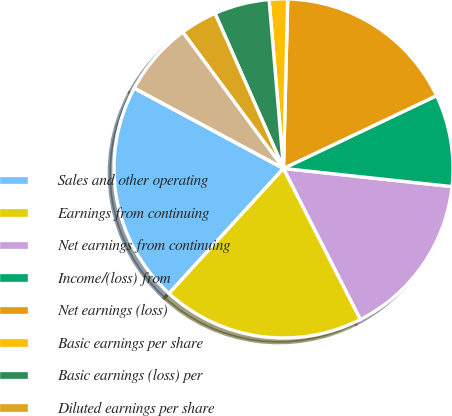Convert chart to OTSL. <chart><loc_0><loc_0><loc_500><loc_500><pie_chart><fcel>Sales and other operating<fcel>Earnings from continuing<fcel>Net earnings from continuing<fcel>Income/(loss) from<fcel>Net earnings (loss)<fcel>Basic earnings per share<fcel>Basic earnings (loss) per<fcel>Diluted earnings per share<fcel>Diluted earnings (loss) per<fcel>Cash dividends paid per share<nl><fcel>21.05%<fcel>19.3%<fcel>15.79%<fcel>8.77%<fcel>17.54%<fcel>1.75%<fcel>5.26%<fcel>3.51%<fcel>7.02%<fcel>0.0%<nl></chart> 